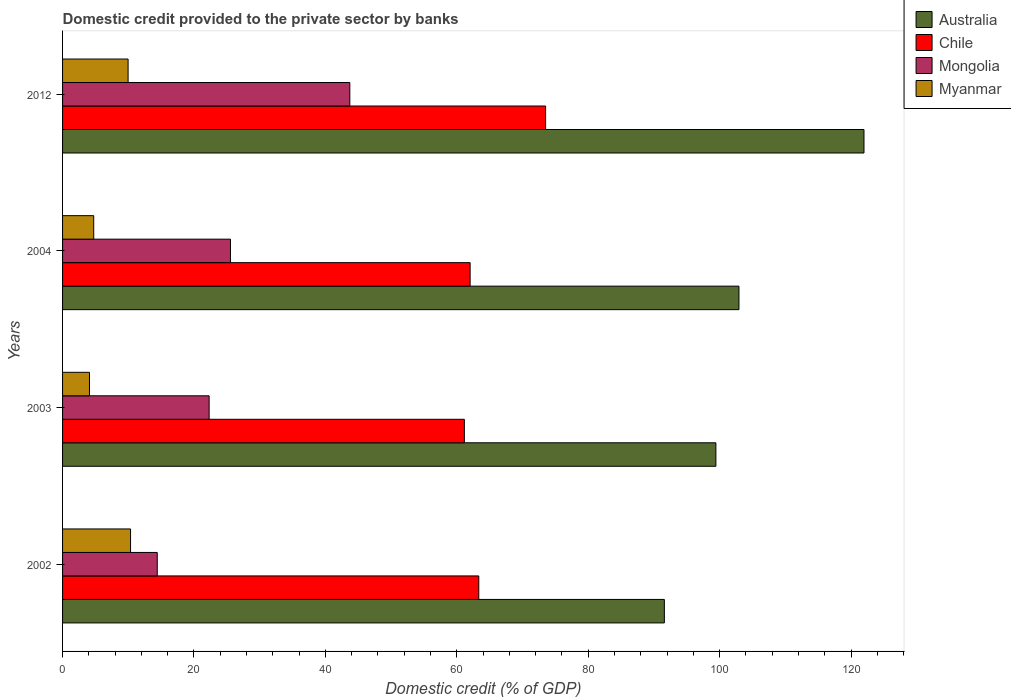How many different coloured bars are there?
Provide a short and direct response. 4. Are the number of bars on each tick of the Y-axis equal?
Keep it short and to the point. Yes. How many bars are there on the 4th tick from the top?
Your answer should be compact. 4. What is the label of the 4th group of bars from the top?
Your answer should be compact. 2002. What is the domestic credit provided to the private sector by banks in Myanmar in 2012?
Your answer should be compact. 9.97. Across all years, what is the maximum domestic credit provided to the private sector by banks in Mongolia?
Your answer should be very brief. 43.72. Across all years, what is the minimum domestic credit provided to the private sector by banks in Mongolia?
Provide a succinct answer. 14.41. In which year was the domestic credit provided to the private sector by banks in Myanmar maximum?
Keep it short and to the point. 2002. What is the total domestic credit provided to the private sector by banks in Chile in the graph?
Your response must be concise. 260.03. What is the difference between the domestic credit provided to the private sector by banks in Mongolia in 2003 and that in 2012?
Ensure brevity in your answer.  -21.41. What is the difference between the domestic credit provided to the private sector by banks in Chile in 2003 and the domestic credit provided to the private sector by banks in Australia in 2012?
Offer a terse response. -60.82. What is the average domestic credit provided to the private sector by banks in Chile per year?
Your answer should be very brief. 65.01. In the year 2012, what is the difference between the domestic credit provided to the private sector by banks in Myanmar and domestic credit provided to the private sector by banks in Chile?
Provide a short and direct response. -63.54. In how many years, is the domestic credit provided to the private sector by banks in Mongolia greater than 8 %?
Make the answer very short. 4. What is the ratio of the domestic credit provided to the private sector by banks in Mongolia in 2002 to that in 2004?
Offer a very short reply. 0.56. What is the difference between the highest and the second highest domestic credit provided to the private sector by banks in Chile?
Offer a terse response. 10.17. What is the difference between the highest and the lowest domestic credit provided to the private sector by banks in Myanmar?
Your answer should be compact. 6.25. What does the 2nd bar from the top in 2004 represents?
Ensure brevity in your answer.  Mongolia. What does the 4th bar from the bottom in 2012 represents?
Ensure brevity in your answer.  Myanmar. Is it the case that in every year, the sum of the domestic credit provided to the private sector by banks in Myanmar and domestic credit provided to the private sector by banks in Australia is greater than the domestic credit provided to the private sector by banks in Mongolia?
Your answer should be very brief. Yes. Are all the bars in the graph horizontal?
Ensure brevity in your answer.  Yes. How many years are there in the graph?
Make the answer very short. 4. What is the difference between two consecutive major ticks on the X-axis?
Offer a very short reply. 20. Are the values on the major ticks of X-axis written in scientific E-notation?
Your answer should be very brief. No. Does the graph contain any zero values?
Your answer should be compact. No. Where does the legend appear in the graph?
Offer a terse response. Top right. How are the legend labels stacked?
Offer a very short reply. Vertical. What is the title of the graph?
Your response must be concise. Domestic credit provided to the private sector by banks. Does "Arab World" appear as one of the legend labels in the graph?
Provide a succinct answer. No. What is the label or title of the X-axis?
Your answer should be compact. Domestic credit (% of GDP). What is the Domestic credit (% of GDP) of Australia in 2002?
Your response must be concise. 91.59. What is the Domestic credit (% of GDP) in Chile in 2002?
Provide a succinct answer. 63.34. What is the Domestic credit (% of GDP) in Mongolia in 2002?
Give a very brief answer. 14.41. What is the Domestic credit (% of GDP) in Myanmar in 2002?
Keep it short and to the point. 10.34. What is the Domestic credit (% of GDP) of Australia in 2003?
Provide a succinct answer. 99.43. What is the Domestic credit (% of GDP) of Chile in 2003?
Your response must be concise. 61.15. What is the Domestic credit (% of GDP) in Mongolia in 2003?
Keep it short and to the point. 22.31. What is the Domestic credit (% of GDP) of Myanmar in 2003?
Your answer should be compact. 4.1. What is the Domestic credit (% of GDP) in Australia in 2004?
Keep it short and to the point. 102.94. What is the Domestic credit (% of GDP) of Chile in 2004?
Offer a terse response. 62.03. What is the Domestic credit (% of GDP) of Mongolia in 2004?
Offer a very short reply. 25.55. What is the Domestic credit (% of GDP) of Myanmar in 2004?
Offer a terse response. 4.74. What is the Domestic credit (% of GDP) of Australia in 2012?
Provide a short and direct response. 121.97. What is the Domestic credit (% of GDP) in Chile in 2012?
Provide a succinct answer. 73.51. What is the Domestic credit (% of GDP) of Mongolia in 2012?
Keep it short and to the point. 43.72. What is the Domestic credit (% of GDP) in Myanmar in 2012?
Offer a very short reply. 9.97. Across all years, what is the maximum Domestic credit (% of GDP) of Australia?
Your response must be concise. 121.97. Across all years, what is the maximum Domestic credit (% of GDP) of Chile?
Ensure brevity in your answer.  73.51. Across all years, what is the maximum Domestic credit (% of GDP) of Mongolia?
Ensure brevity in your answer.  43.72. Across all years, what is the maximum Domestic credit (% of GDP) in Myanmar?
Provide a succinct answer. 10.34. Across all years, what is the minimum Domestic credit (% of GDP) in Australia?
Provide a short and direct response. 91.59. Across all years, what is the minimum Domestic credit (% of GDP) of Chile?
Your answer should be very brief. 61.15. Across all years, what is the minimum Domestic credit (% of GDP) of Mongolia?
Provide a succinct answer. 14.41. Across all years, what is the minimum Domestic credit (% of GDP) in Myanmar?
Offer a terse response. 4.1. What is the total Domestic credit (% of GDP) in Australia in the graph?
Offer a very short reply. 415.93. What is the total Domestic credit (% of GDP) in Chile in the graph?
Your answer should be compact. 260.03. What is the total Domestic credit (% of GDP) in Mongolia in the graph?
Offer a terse response. 105.99. What is the total Domestic credit (% of GDP) in Myanmar in the graph?
Your answer should be very brief. 29.15. What is the difference between the Domestic credit (% of GDP) of Australia in 2002 and that in 2003?
Offer a very short reply. -7.84. What is the difference between the Domestic credit (% of GDP) in Chile in 2002 and that in 2003?
Make the answer very short. 2.19. What is the difference between the Domestic credit (% of GDP) in Mongolia in 2002 and that in 2003?
Offer a very short reply. -7.9. What is the difference between the Domestic credit (% of GDP) of Myanmar in 2002 and that in 2003?
Your answer should be compact. 6.25. What is the difference between the Domestic credit (% of GDP) in Australia in 2002 and that in 2004?
Your response must be concise. -11.35. What is the difference between the Domestic credit (% of GDP) in Chile in 2002 and that in 2004?
Your answer should be compact. 1.32. What is the difference between the Domestic credit (% of GDP) of Mongolia in 2002 and that in 2004?
Your answer should be compact. -11.14. What is the difference between the Domestic credit (% of GDP) in Myanmar in 2002 and that in 2004?
Give a very brief answer. 5.6. What is the difference between the Domestic credit (% of GDP) in Australia in 2002 and that in 2012?
Your response must be concise. -30.38. What is the difference between the Domestic credit (% of GDP) of Chile in 2002 and that in 2012?
Your answer should be very brief. -10.17. What is the difference between the Domestic credit (% of GDP) of Mongolia in 2002 and that in 2012?
Your response must be concise. -29.31. What is the difference between the Domestic credit (% of GDP) in Myanmar in 2002 and that in 2012?
Provide a short and direct response. 0.37. What is the difference between the Domestic credit (% of GDP) of Australia in 2003 and that in 2004?
Offer a terse response. -3.51. What is the difference between the Domestic credit (% of GDP) in Chile in 2003 and that in 2004?
Your response must be concise. -0.88. What is the difference between the Domestic credit (% of GDP) of Mongolia in 2003 and that in 2004?
Your response must be concise. -3.25. What is the difference between the Domestic credit (% of GDP) of Myanmar in 2003 and that in 2004?
Ensure brevity in your answer.  -0.64. What is the difference between the Domestic credit (% of GDP) of Australia in 2003 and that in 2012?
Your answer should be compact. -22.54. What is the difference between the Domestic credit (% of GDP) of Chile in 2003 and that in 2012?
Your response must be concise. -12.36. What is the difference between the Domestic credit (% of GDP) of Mongolia in 2003 and that in 2012?
Make the answer very short. -21.41. What is the difference between the Domestic credit (% of GDP) in Myanmar in 2003 and that in 2012?
Make the answer very short. -5.88. What is the difference between the Domestic credit (% of GDP) in Australia in 2004 and that in 2012?
Your answer should be compact. -19.03. What is the difference between the Domestic credit (% of GDP) in Chile in 2004 and that in 2012?
Provide a succinct answer. -11.49. What is the difference between the Domestic credit (% of GDP) of Mongolia in 2004 and that in 2012?
Offer a terse response. -18.16. What is the difference between the Domestic credit (% of GDP) in Myanmar in 2004 and that in 2012?
Provide a short and direct response. -5.23. What is the difference between the Domestic credit (% of GDP) in Australia in 2002 and the Domestic credit (% of GDP) in Chile in 2003?
Your response must be concise. 30.44. What is the difference between the Domestic credit (% of GDP) in Australia in 2002 and the Domestic credit (% of GDP) in Mongolia in 2003?
Provide a succinct answer. 69.28. What is the difference between the Domestic credit (% of GDP) of Australia in 2002 and the Domestic credit (% of GDP) of Myanmar in 2003?
Provide a succinct answer. 87.49. What is the difference between the Domestic credit (% of GDP) in Chile in 2002 and the Domestic credit (% of GDP) in Mongolia in 2003?
Make the answer very short. 41.04. What is the difference between the Domestic credit (% of GDP) in Chile in 2002 and the Domestic credit (% of GDP) in Myanmar in 2003?
Ensure brevity in your answer.  59.25. What is the difference between the Domestic credit (% of GDP) in Mongolia in 2002 and the Domestic credit (% of GDP) in Myanmar in 2003?
Provide a succinct answer. 10.31. What is the difference between the Domestic credit (% of GDP) of Australia in 2002 and the Domestic credit (% of GDP) of Chile in 2004?
Provide a succinct answer. 29.56. What is the difference between the Domestic credit (% of GDP) of Australia in 2002 and the Domestic credit (% of GDP) of Mongolia in 2004?
Make the answer very short. 66.03. What is the difference between the Domestic credit (% of GDP) in Australia in 2002 and the Domestic credit (% of GDP) in Myanmar in 2004?
Give a very brief answer. 86.85. What is the difference between the Domestic credit (% of GDP) of Chile in 2002 and the Domestic credit (% of GDP) of Mongolia in 2004?
Provide a short and direct response. 37.79. What is the difference between the Domestic credit (% of GDP) in Chile in 2002 and the Domestic credit (% of GDP) in Myanmar in 2004?
Your answer should be compact. 58.6. What is the difference between the Domestic credit (% of GDP) of Mongolia in 2002 and the Domestic credit (% of GDP) of Myanmar in 2004?
Ensure brevity in your answer.  9.67. What is the difference between the Domestic credit (% of GDP) of Australia in 2002 and the Domestic credit (% of GDP) of Chile in 2012?
Your response must be concise. 18.08. What is the difference between the Domestic credit (% of GDP) of Australia in 2002 and the Domestic credit (% of GDP) of Mongolia in 2012?
Ensure brevity in your answer.  47.87. What is the difference between the Domestic credit (% of GDP) in Australia in 2002 and the Domestic credit (% of GDP) in Myanmar in 2012?
Make the answer very short. 81.61. What is the difference between the Domestic credit (% of GDP) of Chile in 2002 and the Domestic credit (% of GDP) of Mongolia in 2012?
Make the answer very short. 19.63. What is the difference between the Domestic credit (% of GDP) in Chile in 2002 and the Domestic credit (% of GDP) in Myanmar in 2012?
Keep it short and to the point. 53.37. What is the difference between the Domestic credit (% of GDP) in Mongolia in 2002 and the Domestic credit (% of GDP) in Myanmar in 2012?
Your answer should be very brief. 4.44. What is the difference between the Domestic credit (% of GDP) of Australia in 2003 and the Domestic credit (% of GDP) of Chile in 2004?
Offer a terse response. 37.4. What is the difference between the Domestic credit (% of GDP) in Australia in 2003 and the Domestic credit (% of GDP) in Mongolia in 2004?
Provide a succinct answer. 73.88. What is the difference between the Domestic credit (% of GDP) of Australia in 2003 and the Domestic credit (% of GDP) of Myanmar in 2004?
Make the answer very short. 94.69. What is the difference between the Domestic credit (% of GDP) in Chile in 2003 and the Domestic credit (% of GDP) in Mongolia in 2004?
Provide a succinct answer. 35.6. What is the difference between the Domestic credit (% of GDP) in Chile in 2003 and the Domestic credit (% of GDP) in Myanmar in 2004?
Provide a short and direct response. 56.41. What is the difference between the Domestic credit (% of GDP) in Mongolia in 2003 and the Domestic credit (% of GDP) in Myanmar in 2004?
Make the answer very short. 17.57. What is the difference between the Domestic credit (% of GDP) in Australia in 2003 and the Domestic credit (% of GDP) in Chile in 2012?
Offer a very short reply. 25.92. What is the difference between the Domestic credit (% of GDP) in Australia in 2003 and the Domestic credit (% of GDP) in Mongolia in 2012?
Make the answer very short. 55.71. What is the difference between the Domestic credit (% of GDP) in Australia in 2003 and the Domestic credit (% of GDP) in Myanmar in 2012?
Ensure brevity in your answer.  89.46. What is the difference between the Domestic credit (% of GDP) of Chile in 2003 and the Domestic credit (% of GDP) of Mongolia in 2012?
Ensure brevity in your answer.  17.43. What is the difference between the Domestic credit (% of GDP) of Chile in 2003 and the Domestic credit (% of GDP) of Myanmar in 2012?
Your answer should be compact. 51.18. What is the difference between the Domestic credit (% of GDP) in Mongolia in 2003 and the Domestic credit (% of GDP) in Myanmar in 2012?
Keep it short and to the point. 12.33. What is the difference between the Domestic credit (% of GDP) in Australia in 2004 and the Domestic credit (% of GDP) in Chile in 2012?
Offer a terse response. 29.43. What is the difference between the Domestic credit (% of GDP) of Australia in 2004 and the Domestic credit (% of GDP) of Mongolia in 2012?
Your response must be concise. 59.22. What is the difference between the Domestic credit (% of GDP) of Australia in 2004 and the Domestic credit (% of GDP) of Myanmar in 2012?
Offer a very short reply. 92.97. What is the difference between the Domestic credit (% of GDP) in Chile in 2004 and the Domestic credit (% of GDP) in Mongolia in 2012?
Provide a succinct answer. 18.31. What is the difference between the Domestic credit (% of GDP) of Chile in 2004 and the Domestic credit (% of GDP) of Myanmar in 2012?
Give a very brief answer. 52.05. What is the difference between the Domestic credit (% of GDP) in Mongolia in 2004 and the Domestic credit (% of GDP) in Myanmar in 2012?
Give a very brief answer. 15.58. What is the average Domestic credit (% of GDP) of Australia per year?
Offer a terse response. 103.98. What is the average Domestic credit (% of GDP) of Chile per year?
Your answer should be very brief. 65.01. What is the average Domestic credit (% of GDP) in Mongolia per year?
Provide a succinct answer. 26.5. What is the average Domestic credit (% of GDP) in Myanmar per year?
Ensure brevity in your answer.  7.29. In the year 2002, what is the difference between the Domestic credit (% of GDP) of Australia and Domestic credit (% of GDP) of Chile?
Provide a short and direct response. 28.24. In the year 2002, what is the difference between the Domestic credit (% of GDP) of Australia and Domestic credit (% of GDP) of Mongolia?
Your response must be concise. 77.18. In the year 2002, what is the difference between the Domestic credit (% of GDP) of Australia and Domestic credit (% of GDP) of Myanmar?
Offer a terse response. 81.24. In the year 2002, what is the difference between the Domestic credit (% of GDP) of Chile and Domestic credit (% of GDP) of Mongolia?
Offer a terse response. 48.93. In the year 2002, what is the difference between the Domestic credit (% of GDP) of Chile and Domestic credit (% of GDP) of Myanmar?
Your answer should be compact. 53. In the year 2002, what is the difference between the Domestic credit (% of GDP) in Mongolia and Domestic credit (% of GDP) in Myanmar?
Give a very brief answer. 4.07. In the year 2003, what is the difference between the Domestic credit (% of GDP) of Australia and Domestic credit (% of GDP) of Chile?
Give a very brief answer. 38.28. In the year 2003, what is the difference between the Domestic credit (% of GDP) of Australia and Domestic credit (% of GDP) of Mongolia?
Provide a short and direct response. 77.12. In the year 2003, what is the difference between the Domestic credit (% of GDP) in Australia and Domestic credit (% of GDP) in Myanmar?
Give a very brief answer. 95.33. In the year 2003, what is the difference between the Domestic credit (% of GDP) of Chile and Domestic credit (% of GDP) of Mongolia?
Provide a succinct answer. 38.84. In the year 2003, what is the difference between the Domestic credit (% of GDP) in Chile and Domestic credit (% of GDP) in Myanmar?
Offer a very short reply. 57.05. In the year 2003, what is the difference between the Domestic credit (% of GDP) in Mongolia and Domestic credit (% of GDP) in Myanmar?
Provide a short and direct response. 18.21. In the year 2004, what is the difference between the Domestic credit (% of GDP) of Australia and Domestic credit (% of GDP) of Chile?
Your response must be concise. 40.91. In the year 2004, what is the difference between the Domestic credit (% of GDP) of Australia and Domestic credit (% of GDP) of Mongolia?
Make the answer very short. 77.39. In the year 2004, what is the difference between the Domestic credit (% of GDP) of Australia and Domestic credit (% of GDP) of Myanmar?
Provide a short and direct response. 98.2. In the year 2004, what is the difference between the Domestic credit (% of GDP) of Chile and Domestic credit (% of GDP) of Mongolia?
Give a very brief answer. 36.47. In the year 2004, what is the difference between the Domestic credit (% of GDP) of Chile and Domestic credit (% of GDP) of Myanmar?
Give a very brief answer. 57.29. In the year 2004, what is the difference between the Domestic credit (% of GDP) of Mongolia and Domestic credit (% of GDP) of Myanmar?
Offer a terse response. 20.81. In the year 2012, what is the difference between the Domestic credit (% of GDP) of Australia and Domestic credit (% of GDP) of Chile?
Give a very brief answer. 48.46. In the year 2012, what is the difference between the Domestic credit (% of GDP) of Australia and Domestic credit (% of GDP) of Mongolia?
Your response must be concise. 78.25. In the year 2012, what is the difference between the Domestic credit (% of GDP) in Australia and Domestic credit (% of GDP) in Myanmar?
Give a very brief answer. 111.99. In the year 2012, what is the difference between the Domestic credit (% of GDP) of Chile and Domestic credit (% of GDP) of Mongolia?
Offer a terse response. 29.79. In the year 2012, what is the difference between the Domestic credit (% of GDP) in Chile and Domestic credit (% of GDP) in Myanmar?
Provide a succinct answer. 63.54. In the year 2012, what is the difference between the Domestic credit (% of GDP) in Mongolia and Domestic credit (% of GDP) in Myanmar?
Keep it short and to the point. 33.74. What is the ratio of the Domestic credit (% of GDP) in Australia in 2002 to that in 2003?
Provide a short and direct response. 0.92. What is the ratio of the Domestic credit (% of GDP) of Chile in 2002 to that in 2003?
Make the answer very short. 1.04. What is the ratio of the Domestic credit (% of GDP) in Mongolia in 2002 to that in 2003?
Offer a very short reply. 0.65. What is the ratio of the Domestic credit (% of GDP) of Myanmar in 2002 to that in 2003?
Provide a short and direct response. 2.53. What is the ratio of the Domestic credit (% of GDP) in Australia in 2002 to that in 2004?
Ensure brevity in your answer.  0.89. What is the ratio of the Domestic credit (% of GDP) in Chile in 2002 to that in 2004?
Offer a very short reply. 1.02. What is the ratio of the Domestic credit (% of GDP) in Mongolia in 2002 to that in 2004?
Provide a succinct answer. 0.56. What is the ratio of the Domestic credit (% of GDP) of Myanmar in 2002 to that in 2004?
Your answer should be compact. 2.18. What is the ratio of the Domestic credit (% of GDP) in Australia in 2002 to that in 2012?
Your response must be concise. 0.75. What is the ratio of the Domestic credit (% of GDP) in Chile in 2002 to that in 2012?
Offer a terse response. 0.86. What is the ratio of the Domestic credit (% of GDP) of Mongolia in 2002 to that in 2012?
Offer a terse response. 0.33. What is the ratio of the Domestic credit (% of GDP) of Myanmar in 2002 to that in 2012?
Provide a short and direct response. 1.04. What is the ratio of the Domestic credit (% of GDP) in Australia in 2003 to that in 2004?
Your answer should be compact. 0.97. What is the ratio of the Domestic credit (% of GDP) of Chile in 2003 to that in 2004?
Keep it short and to the point. 0.99. What is the ratio of the Domestic credit (% of GDP) in Mongolia in 2003 to that in 2004?
Provide a succinct answer. 0.87. What is the ratio of the Domestic credit (% of GDP) of Myanmar in 2003 to that in 2004?
Your response must be concise. 0.86. What is the ratio of the Domestic credit (% of GDP) in Australia in 2003 to that in 2012?
Keep it short and to the point. 0.82. What is the ratio of the Domestic credit (% of GDP) of Chile in 2003 to that in 2012?
Provide a short and direct response. 0.83. What is the ratio of the Domestic credit (% of GDP) in Mongolia in 2003 to that in 2012?
Your response must be concise. 0.51. What is the ratio of the Domestic credit (% of GDP) in Myanmar in 2003 to that in 2012?
Keep it short and to the point. 0.41. What is the ratio of the Domestic credit (% of GDP) in Australia in 2004 to that in 2012?
Offer a very short reply. 0.84. What is the ratio of the Domestic credit (% of GDP) of Chile in 2004 to that in 2012?
Make the answer very short. 0.84. What is the ratio of the Domestic credit (% of GDP) in Mongolia in 2004 to that in 2012?
Offer a terse response. 0.58. What is the ratio of the Domestic credit (% of GDP) in Myanmar in 2004 to that in 2012?
Make the answer very short. 0.48. What is the difference between the highest and the second highest Domestic credit (% of GDP) of Australia?
Offer a terse response. 19.03. What is the difference between the highest and the second highest Domestic credit (% of GDP) of Chile?
Ensure brevity in your answer.  10.17. What is the difference between the highest and the second highest Domestic credit (% of GDP) of Mongolia?
Your answer should be compact. 18.16. What is the difference between the highest and the second highest Domestic credit (% of GDP) of Myanmar?
Provide a short and direct response. 0.37. What is the difference between the highest and the lowest Domestic credit (% of GDP) of Australia?
Your answer should be compact. 30.38. What is the difference between the highest and the lowest Domestic credit (% of GDP) in Chile?
Offer a terse response. 12.36. What is the difference between the highest and the lowest Domestic credit (% of GDP) of Mongolia?
Your answer should be very brief. 29.31. What is the difference between the highest and the lowest Domestic credit (% of GDP) in Myanmar?
Offer a very short reply. 6.25. 